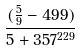<formula> <loc_0><loc_0><loc_500><loc_500>\frac { ( \frac { 5 } { 9 } - 4 9 9 ) } { 5 + 3 5 7 ^ { 2 2 9 } }</formula> 